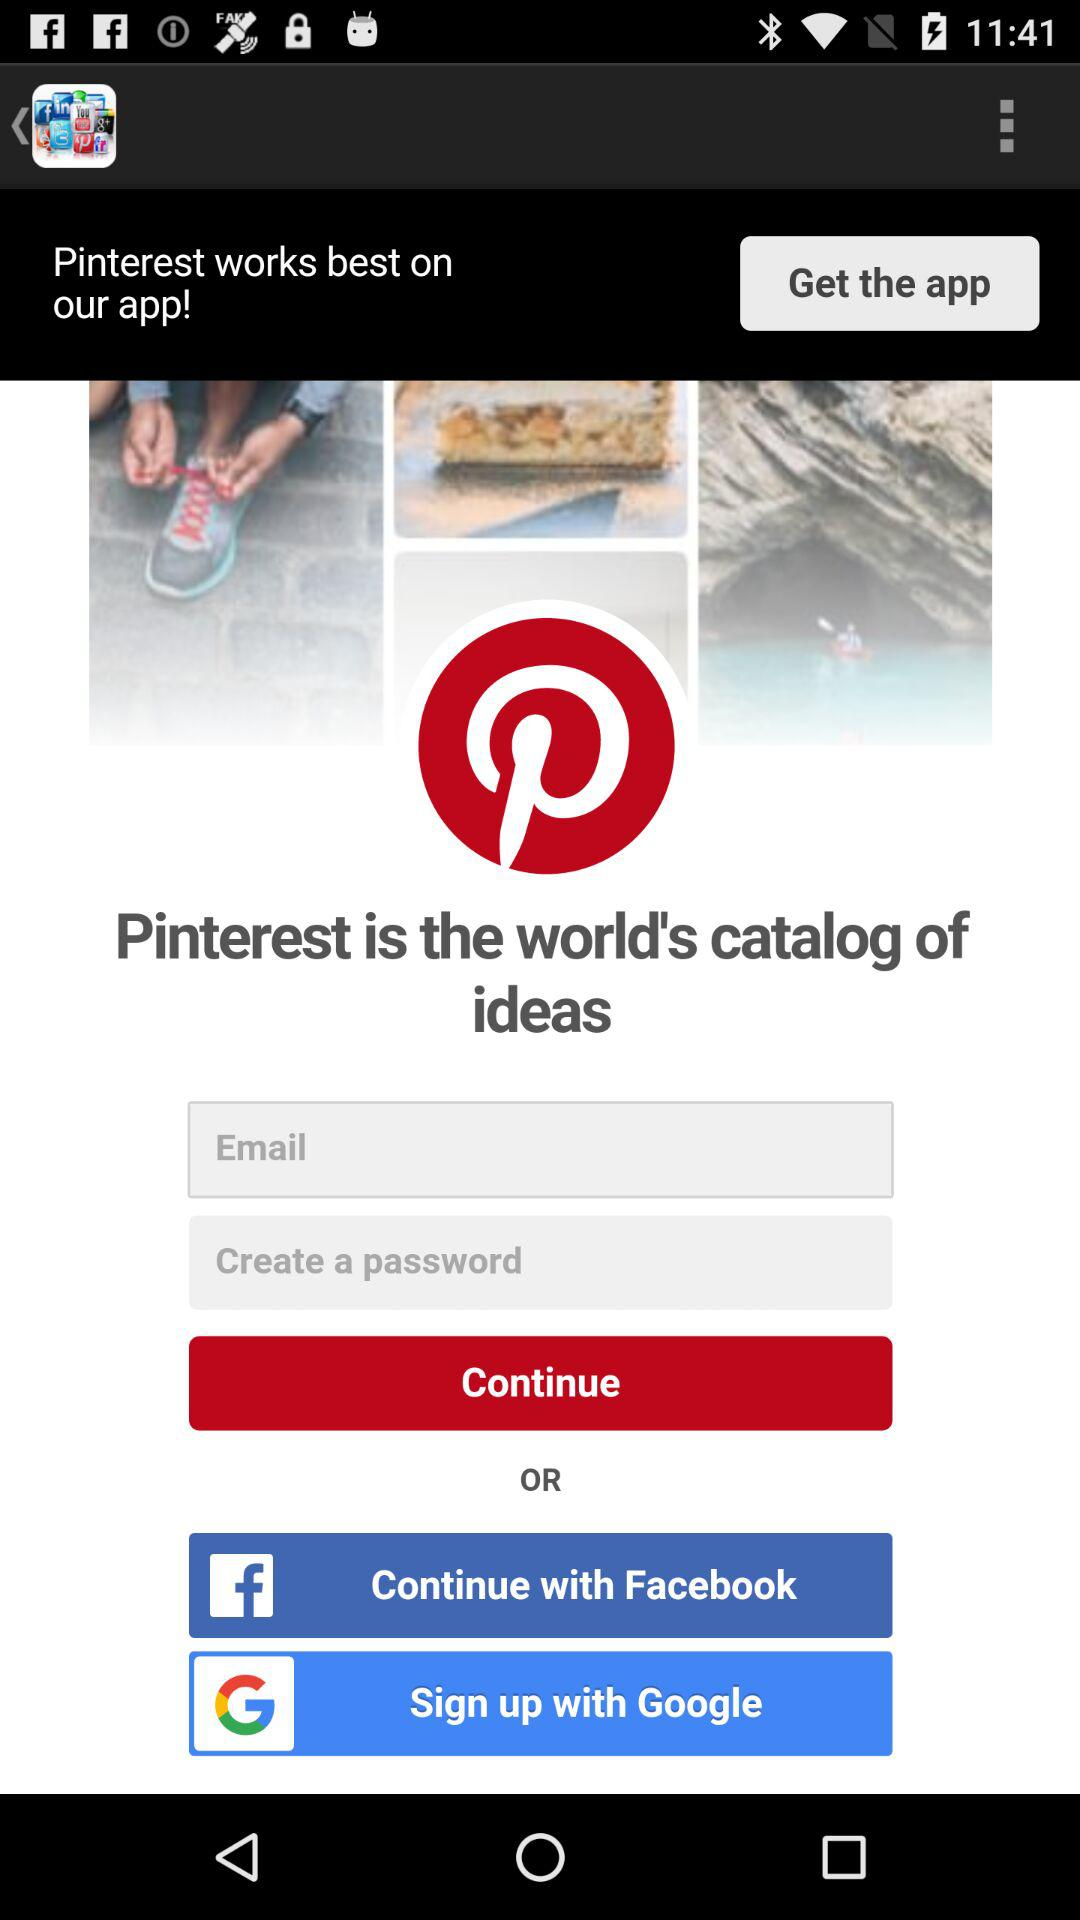What are the different options through which we can sign in? The different options are "Email", "Facebook" and "Google". 